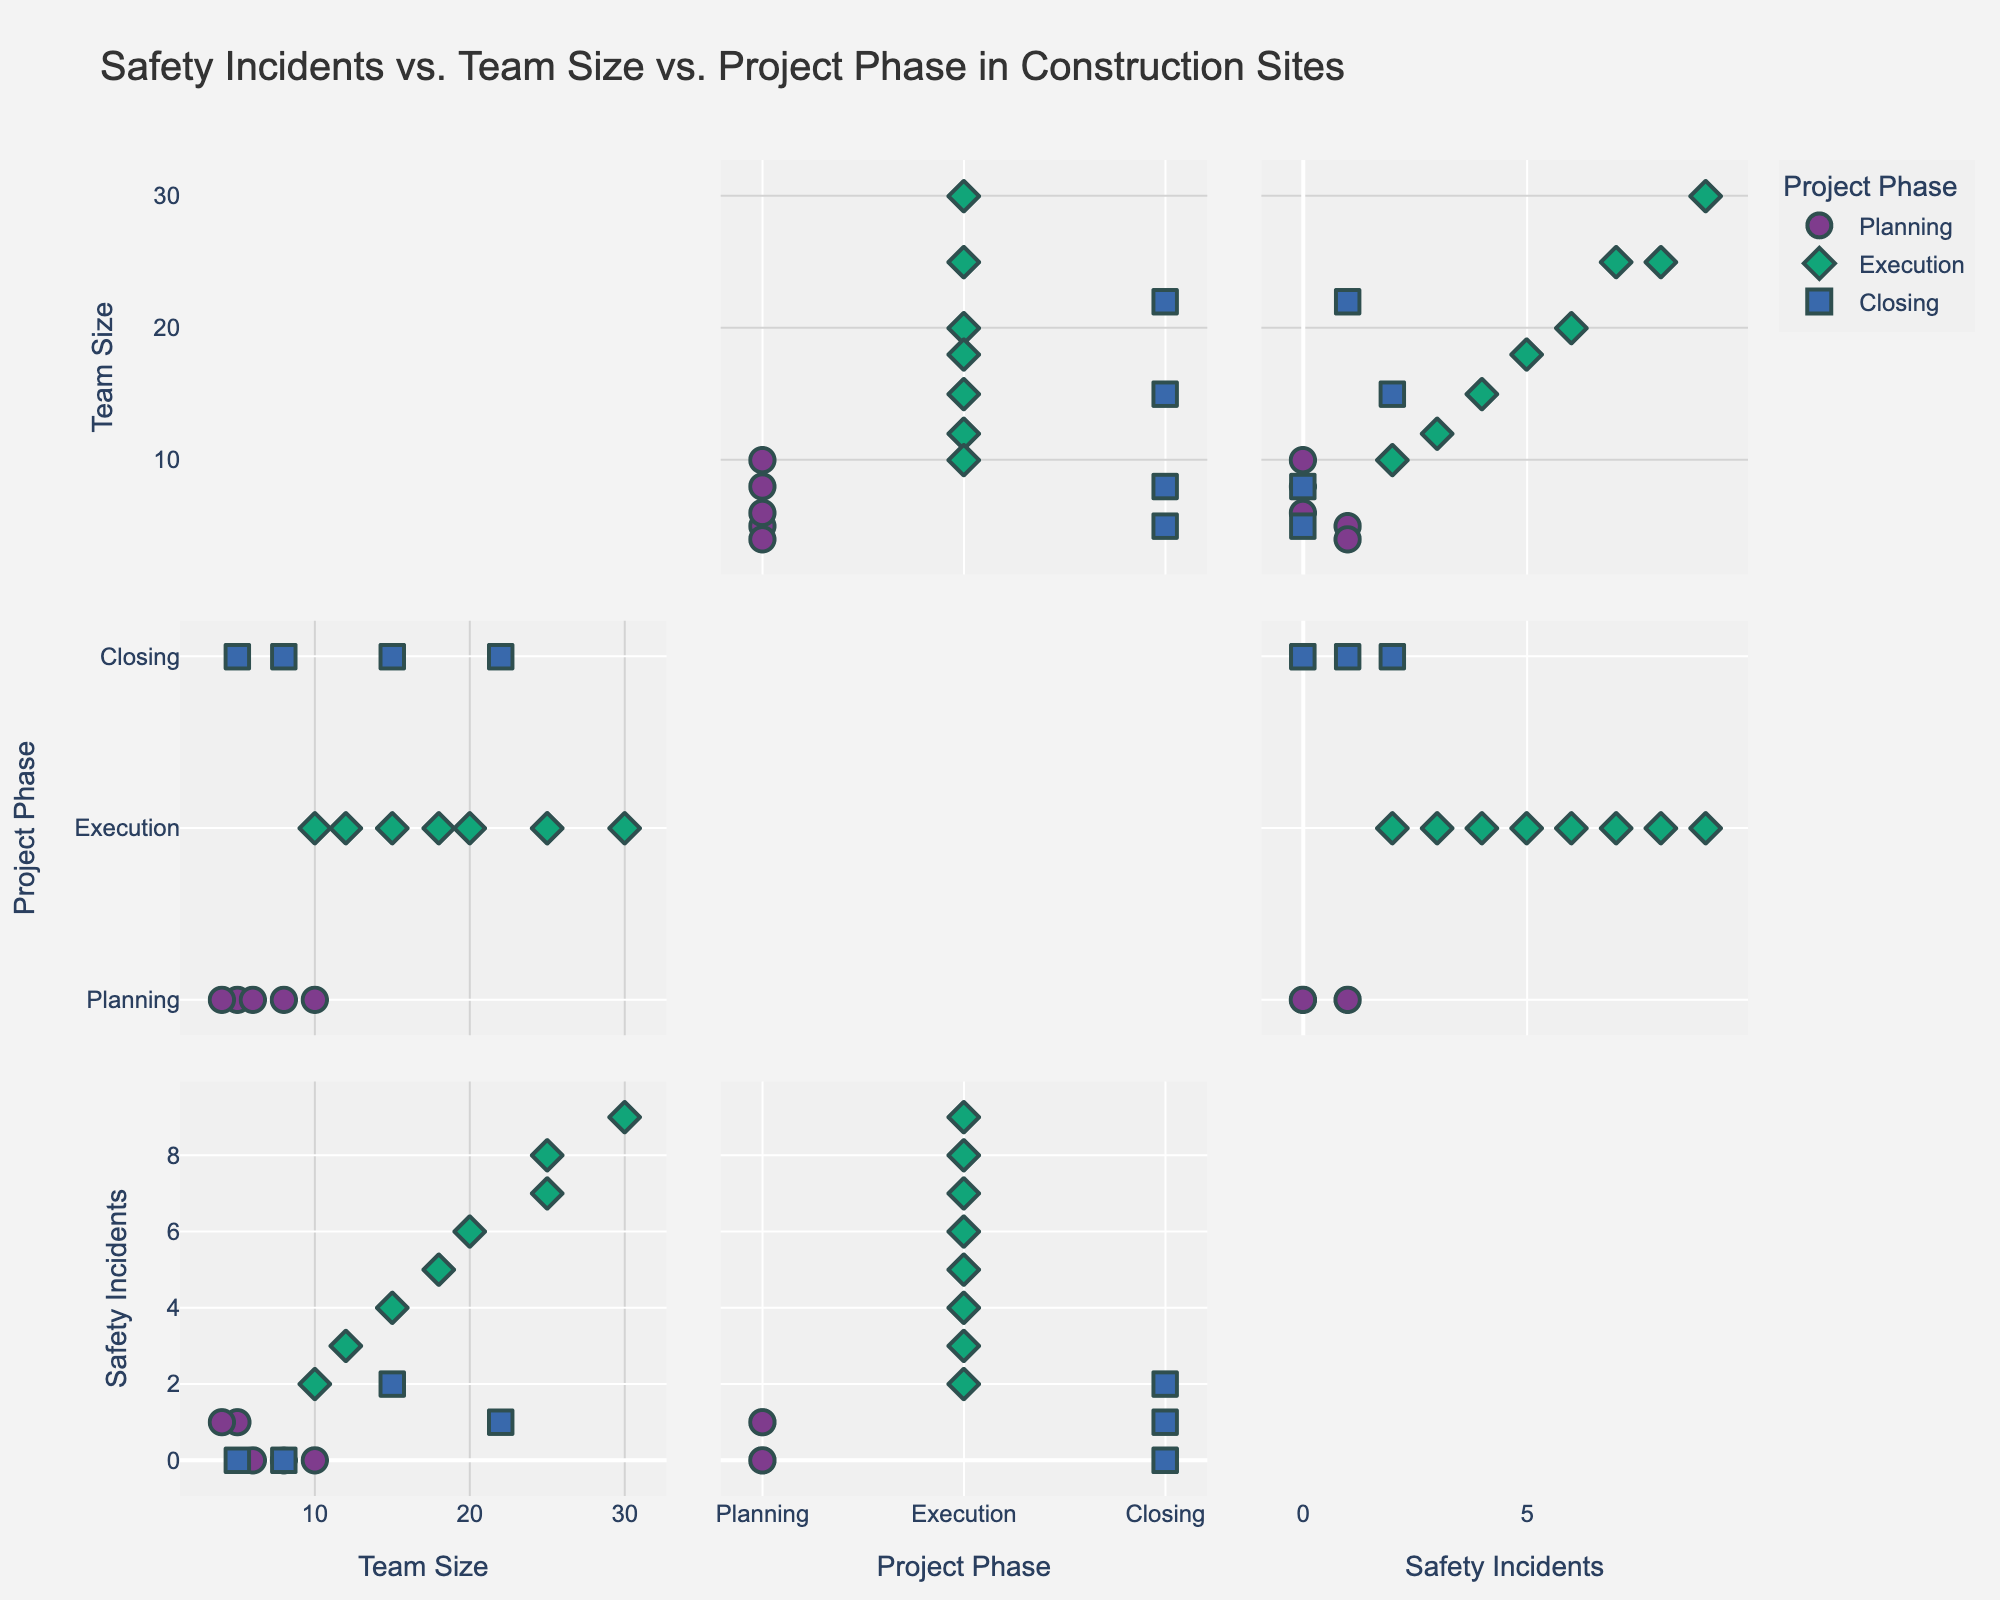How many data points are in the "Planning" phase? Look at the "Project Phase" column for "Planning" and count the data points. There are 5 in total.
Answer: 5 How many safety incidents occur at the largest team size? Find the largest team size, which is 30, and then find the corresponding safety incidents, which is 9.
Answer: 9 Which project phase has the highest average number of safety incidents? Calculate the average number of safety incidents for each phase. "Planning" phase has (1 + 0 + 0 + 1 + 0)/5 = 0.4, "Execution" has (3 + 4 + 6 + 7 + 5 + 8 + 2 + 9)/8 = 5.5, "Closing" has (1 + 0 + 0 + 2)/4 = 0.75. Therefore, "Execution" has the highest average.
Answer: Execution Is there a trend between team size and safety incidents in the "Execution" phase? Compare the team sizes with safety incidents for the "Execution" phase to identify any trends. Higher team sizes generally have more safety incidents.
Answer: Yes In which project phase do the team sizes vary the most? Look at the range of team sizes for each phase. "Planning" phase ranges from 4 to 10, "Execution" ranges from 10 to 30, and "Closing" ranges from 5 to 22. "Execution" shows the most variability in team sizes.
Answer: Execution 